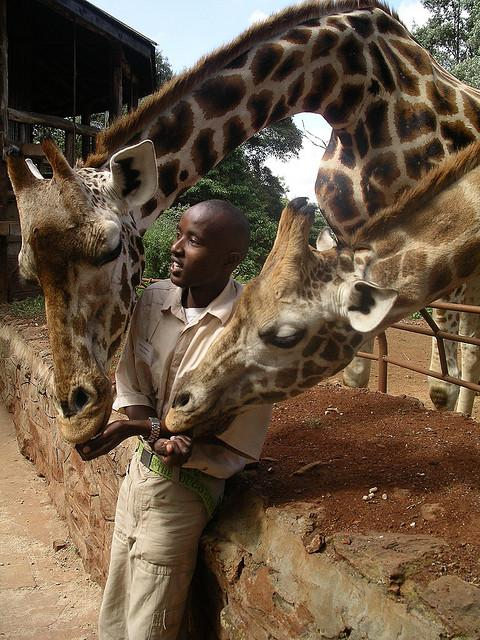What is the man near the giraffes job? zookeeper 